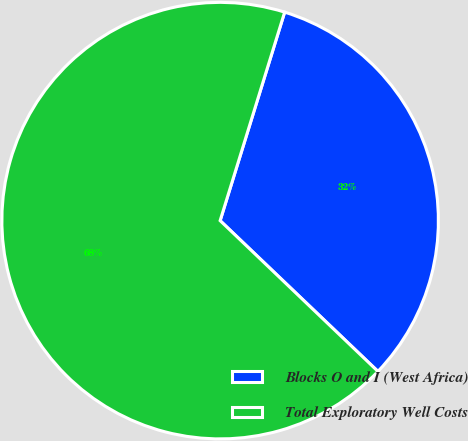<chart> <loc_0><loc_0><loc_500><loc_500><pie_chart><fcel>Blocks O and I (West Africa)<fcel>Total Exploratory Well Costs<nl><fcel>32.36%<fcel>67.64%<nl></chart> 